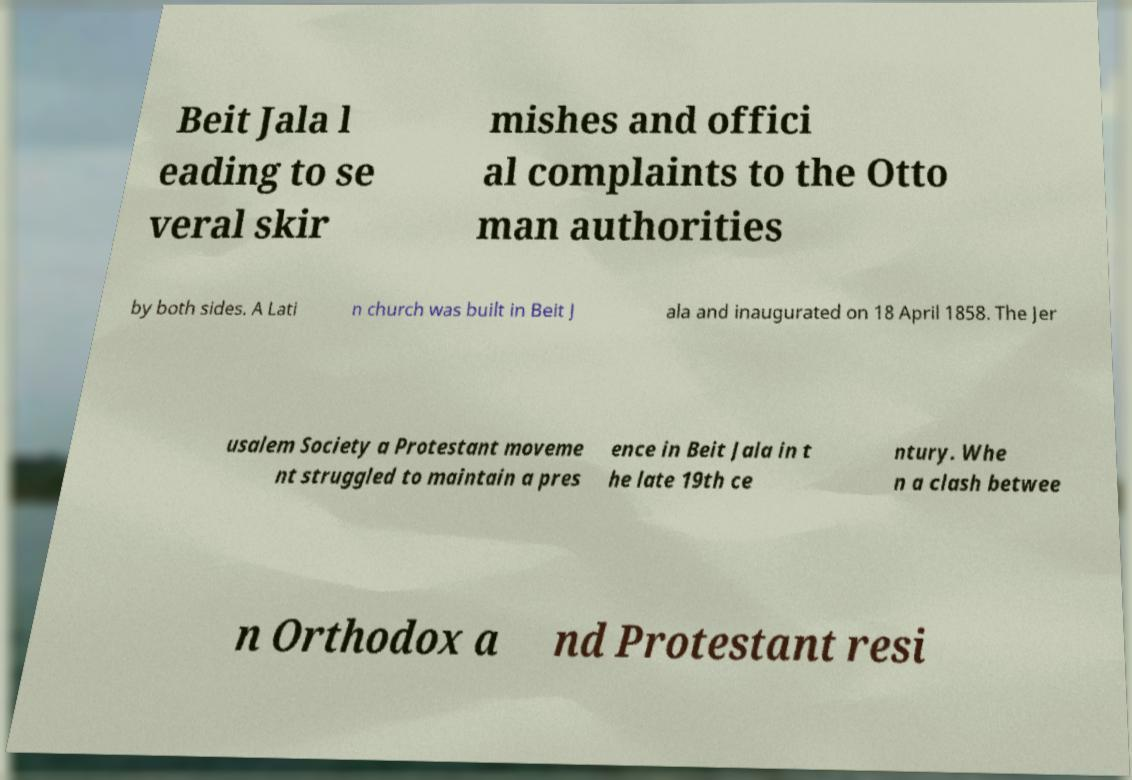Can you read and provide the text displayed in the image?This photo seems to have some interesting text. Can you extract and type it out for me? Beit Jala l eading to se veral skir mishes and offici al complaints to the Otto man authorities by both sides. A Lati n church was built in Beit J ala and inaugurated on 18 April 1858. The Jer usalem Society a Protestant moveme nt struggled to maintain a pres ence in Beit Jala in t he late 19th ce ntury. Whe n a clash betwee n Orthodox a nd Protestant resi 